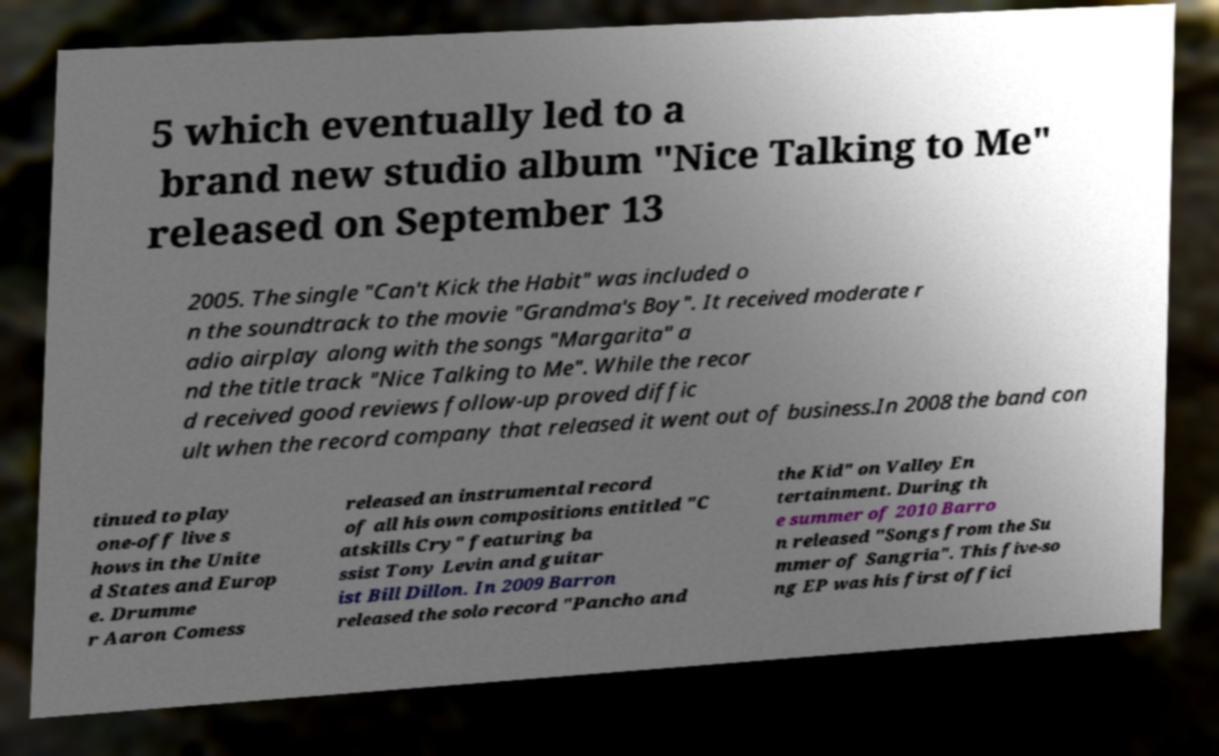There's text embedded in this image that I need extracted. Can you transcribe it verbatim? 5 which eventually led to a brand new studio album "Nice Talking to Me" released on September 13 2005. The single "Can't Kick the Habit" was included o n the soundtrack to the movie "Grandma's Boy". It received moderate r adio airplay along with the songs "Margarita" a nd the title track "Nice Talking to Me". While the recor d received good reviews follow-up proved diffic ult when the record company that released it went out of business.In 2008 the band con tinued to play one-off live s hows in the Unite d States and Europ e. Drumme r Aaron Comess released an instrumental record of all his own compositions entitled "C atskills Cry" featuring ba ssist Tony Levin and guitar ist Bill Dillon. In 2009 Barron released the solo record "Pancho and the Kid" on Valley En tertainment. During th e summer of 2010 Barro n released "Songs from the Su mmer of Sangria". This five-so ng EP was his first offici 